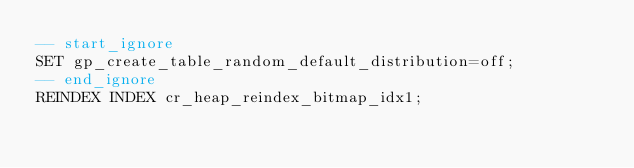<code> <loc_0><loc_0><loc_500><loc_500><_SQL_>-- start_ignore
SET gp_create_table_random_default_distribution=off;
-- end_ignore
REINDEX INDEX cr_heap_reindex_bitmap_idx1;
</code> 